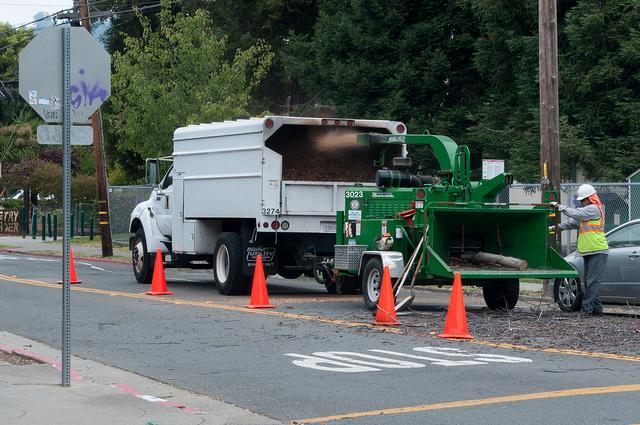How were the purple characters written? Please explain your reasoning. spray can. The man was using a can. 